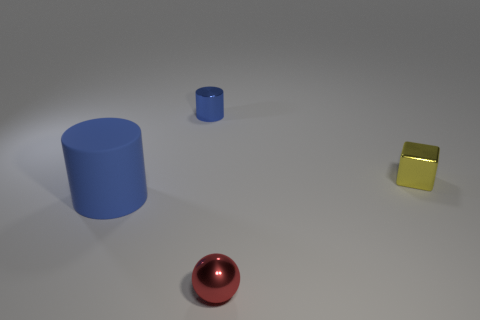There is a big rubber object; is its color the same as the cylinder behind the small yellow metal block?
Make the answer very short. Yes. Are there any other matte cylinders of the same color as the tiny cylinder?
Provide a short and direct response. Yes. Are any tiny red cylinders visible?
Provide a succinct answer. No. Is the shape of the large thing the same as the tiny blue thing?
Make the answer very short. Yes. How many small objects are either balls or green rubber cylinders?
Provide a short and direct response. 1. What is the color of the sphere?
Give a very brief answer. Red. What is the shape of the thing left of the small thing that is behind the tiny yellow object?
Ensure brevity in your answer.  Cylinder. Are there any small yellow objects that have the same material as the tiny red ball?
Make the answer very short. Yes. Do the metal object behind the yellow shiny thing and the small yellow cube have the same size?
Your answer should be compact. Yes. How many green things are either big rubber objects or small shiny cubes?
Ensure brevity in your answer.  0. 